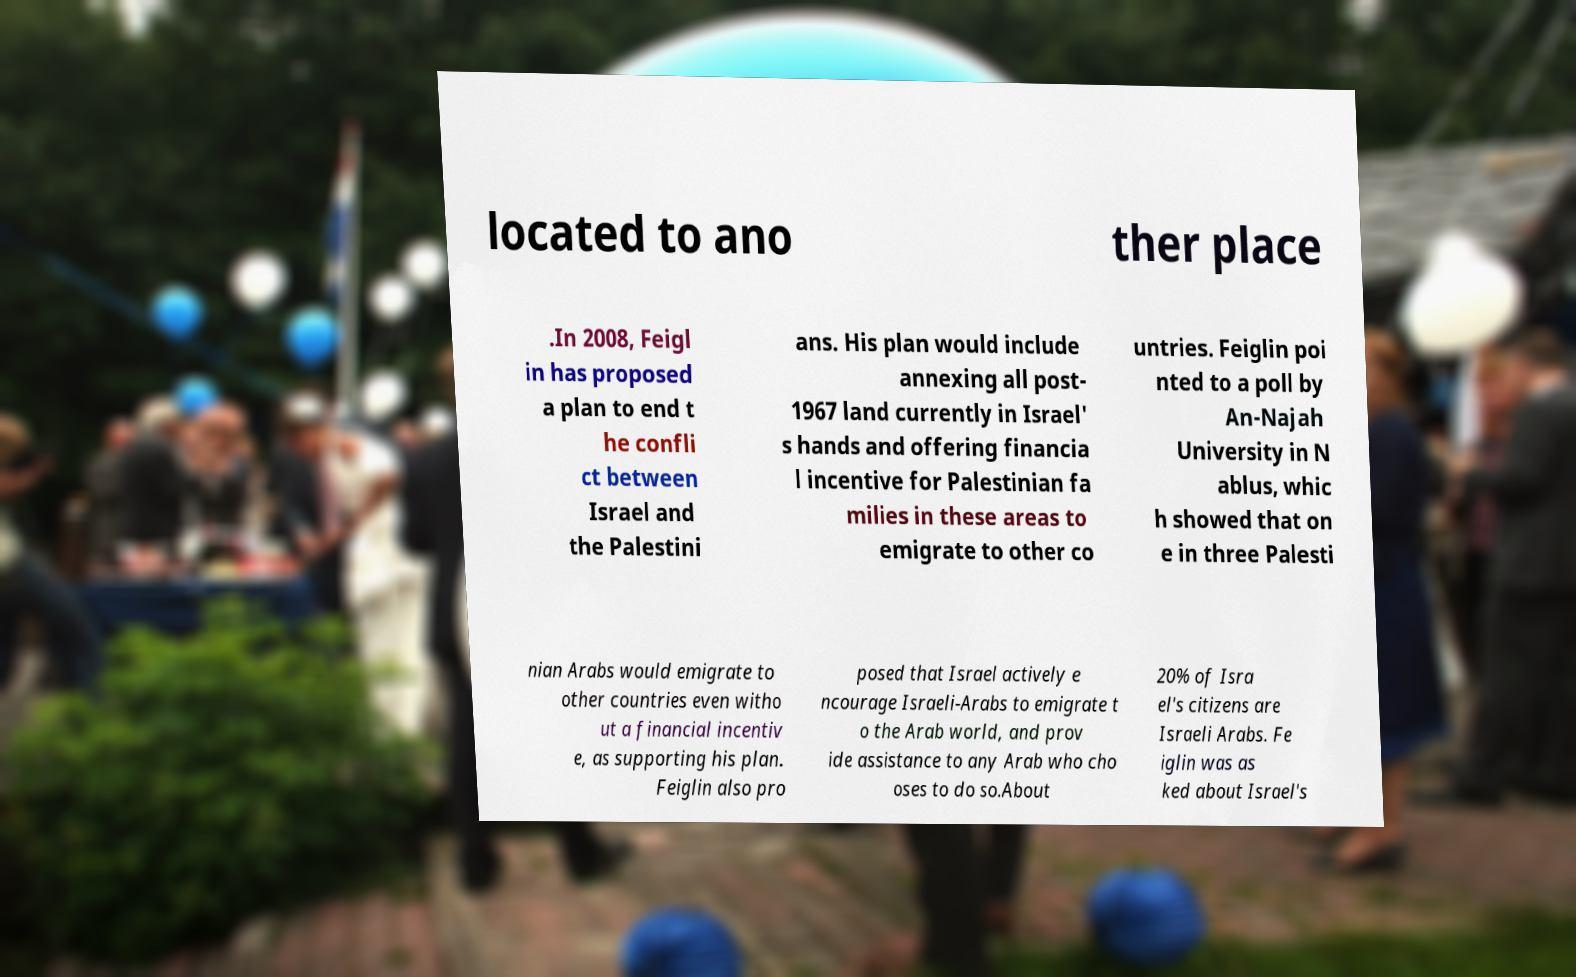I need the written content from this picture converted into text. Can you do that? located to ano ther place .In 2008, Feigl in has proposed a plan to end t he confli ct between Israel and the Palestini ans. His plan would include annexing all post- 1967 land currently in Israel' s hands and offering financia l incentive for Palestinian fa milies in these areas to emigrate to other co untries. Feiglin poi nted to a poll by An-Najah University in N ablus, whic h showed that on e in three Palesti nian Arabs would emigrate to other countries even witho ut a financial incentiv e, as supporting his plan. Feiglin also pro posed that Israel actively e ncourage Israeli-Arabs to emigrate t o the Arab world, and prov ide assistance to any Arab who cho oses to do so.About 20% of Isra el's citizens are Israeli Arabs. Fe iglin was as ked about Israel's 